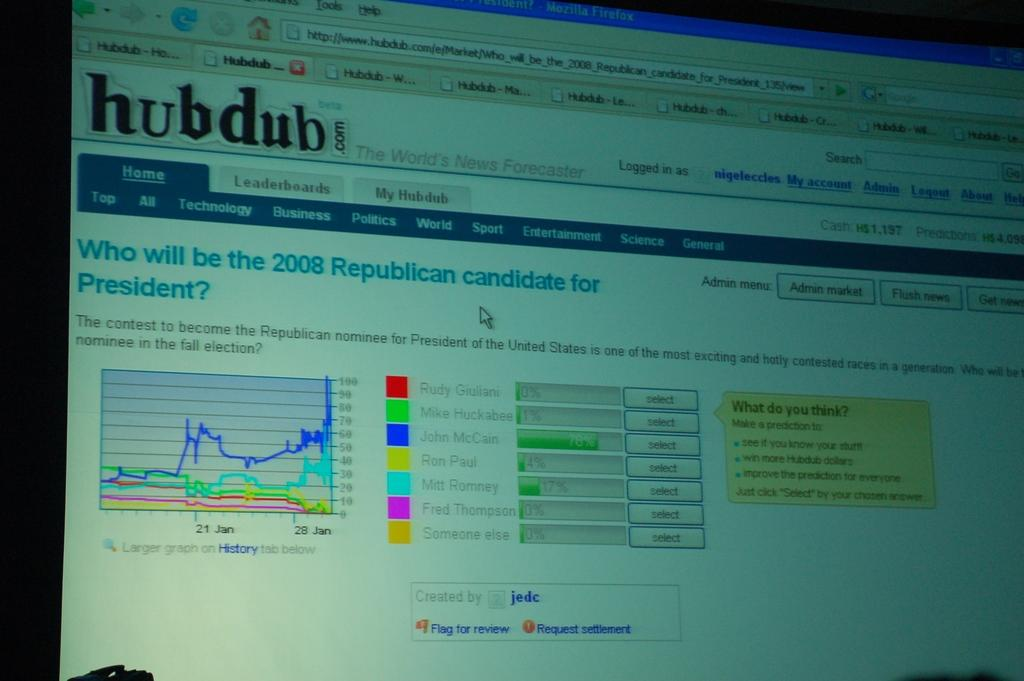<image>
Summarize the visual content of the image. A webpage shows data about the republican presidential candidates. 